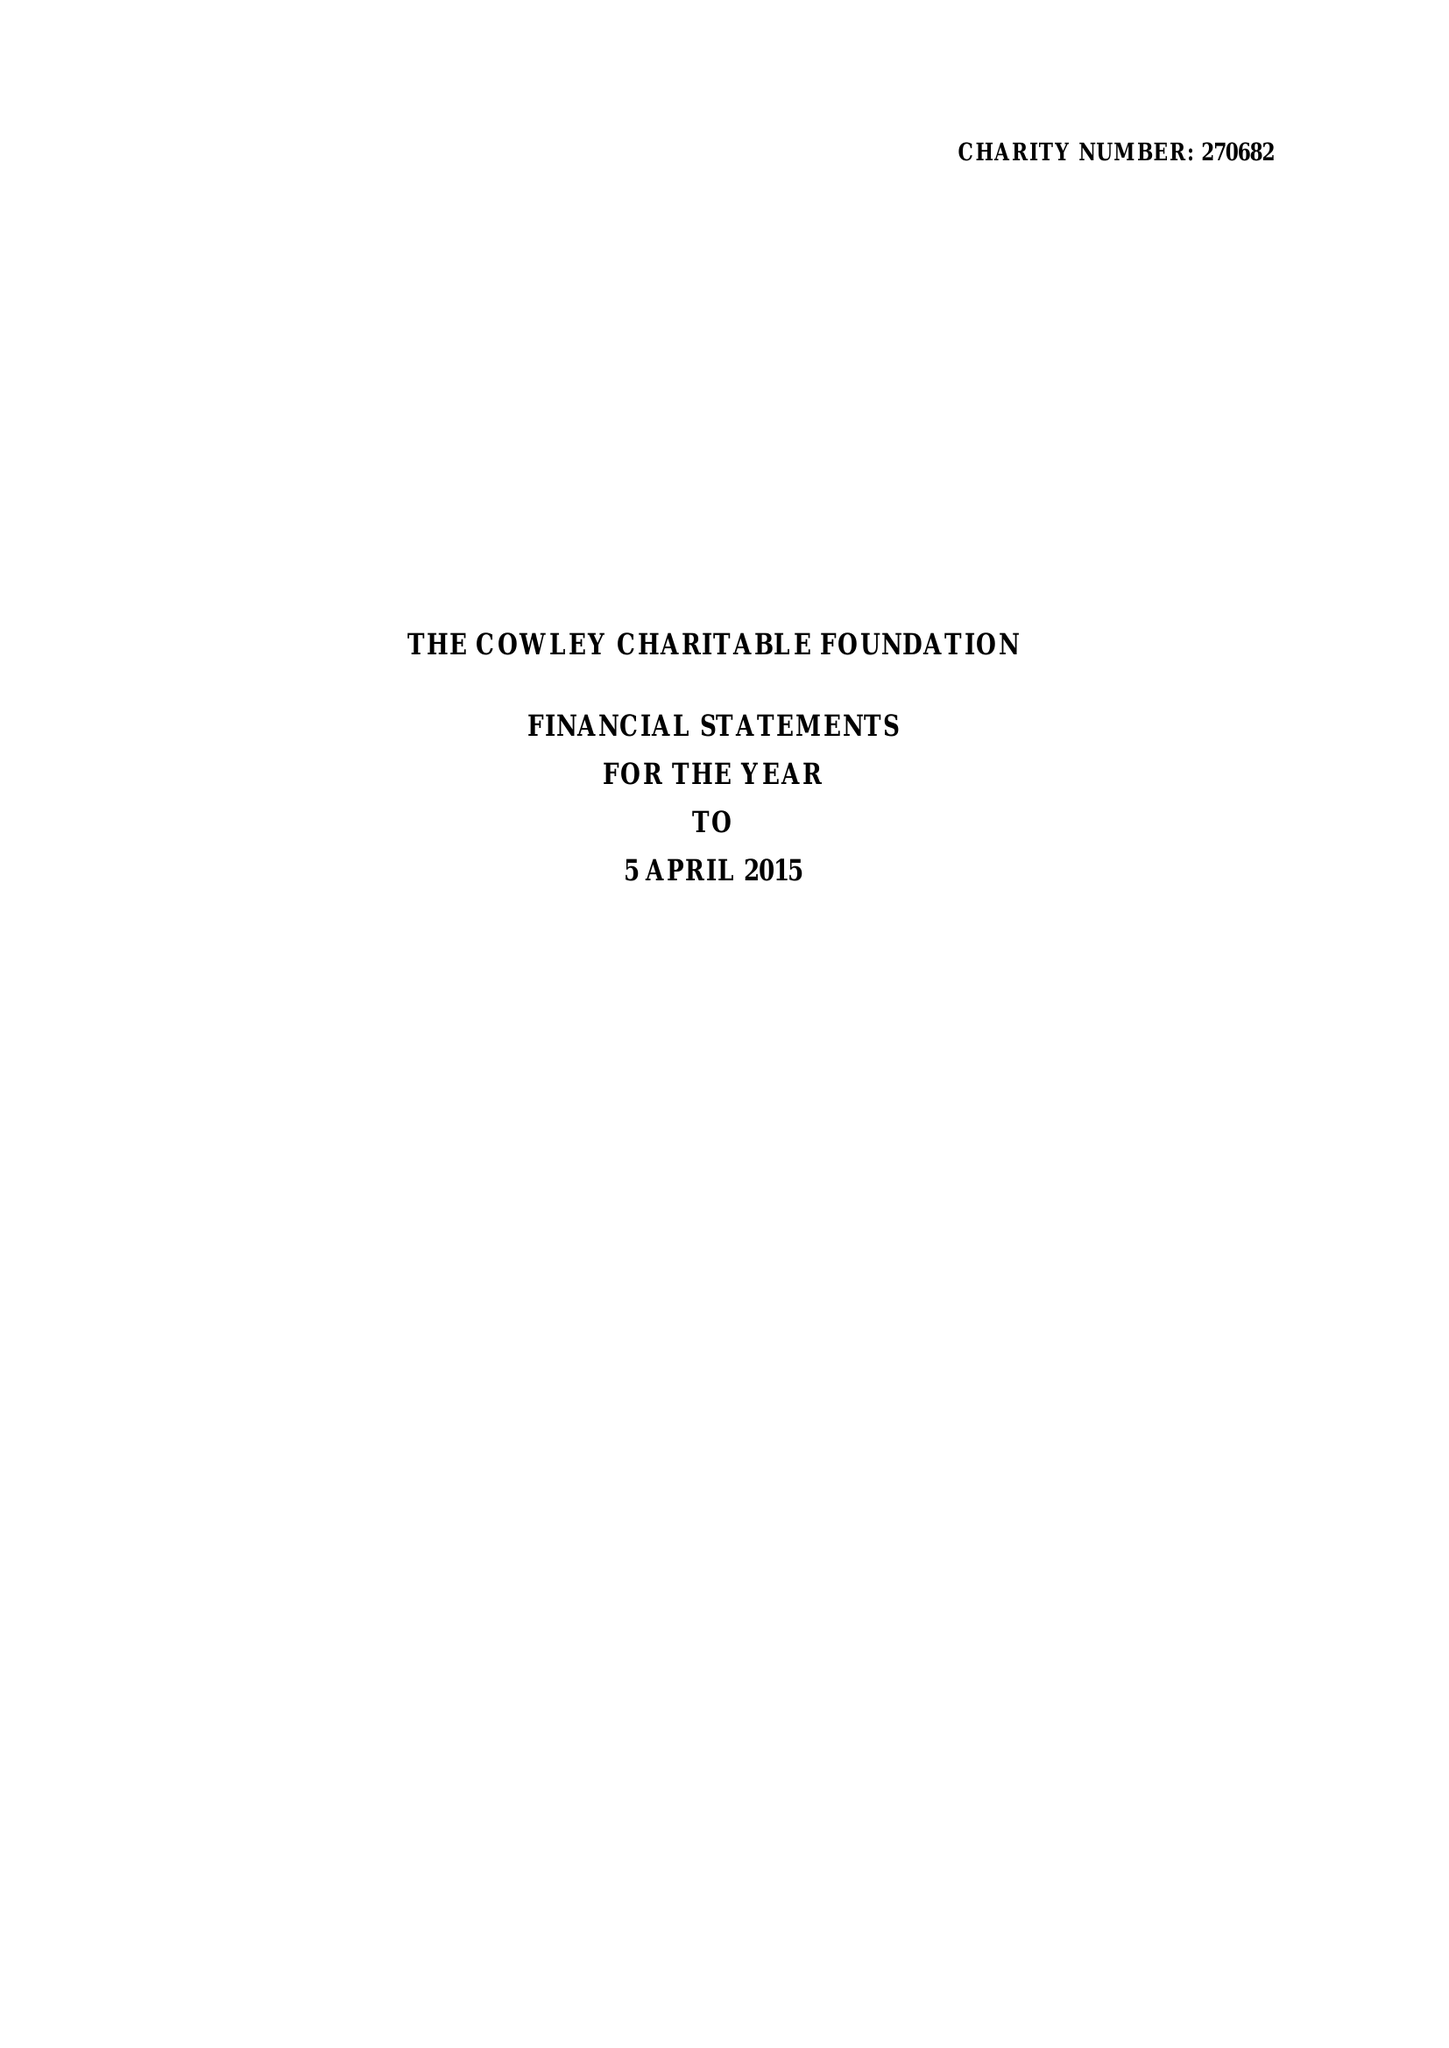What is the value for the charity_number?
Answer the question using a single word or phrase. 270682 